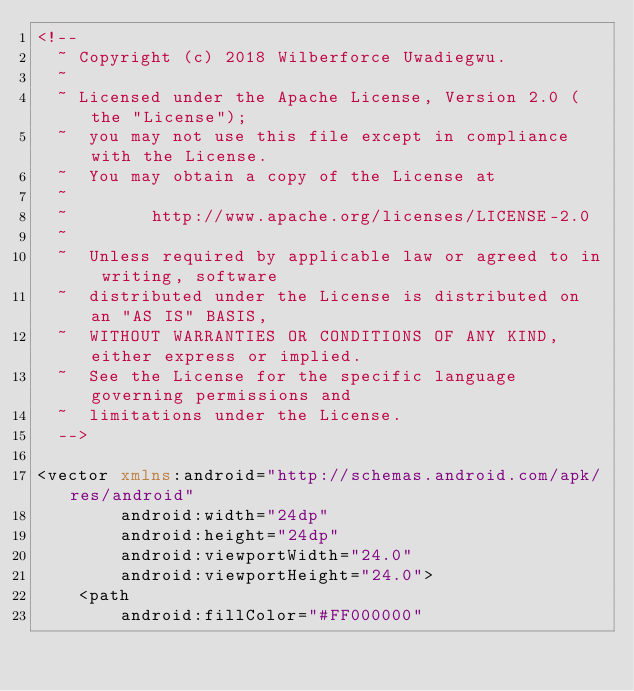<code> <loc_0><loc_0><loc_500><loc_500><_XML_><!--
  ~ Copyright (c) 2018 Wilberforce Uwadiegwu.
  ~
  ~ Licensed under the Apache License, Version 2.0 (the "License");
  ~  you may not use this file except in compliance with the License.
  ~  You may obtain a copy of the License at
  ~
  ~        http://www.apache.org/licenses/LICENSE-2.0
  ~
  ~  Unless required by applicable law or agreed to in writing, software
  ~  distributed under the License is distributed on an "AS IS" BASIS,
  ~  WITHOUT WARRANTIES OR CONDITIONS OF ANY KIND, either express or implied.
  ~  See the License for the specific language governing permissions and
  ~  limitations under the License.
  -->

<vector xmlns:android="http://schemas.android.com/apk/res/android"
        android:width="24dp"
        android:height="24dp"
        android:viewportWidth="24.0"
        android:viewportHeight="24.0">
    <path
        android:fillColor="#FF000000"</code> 